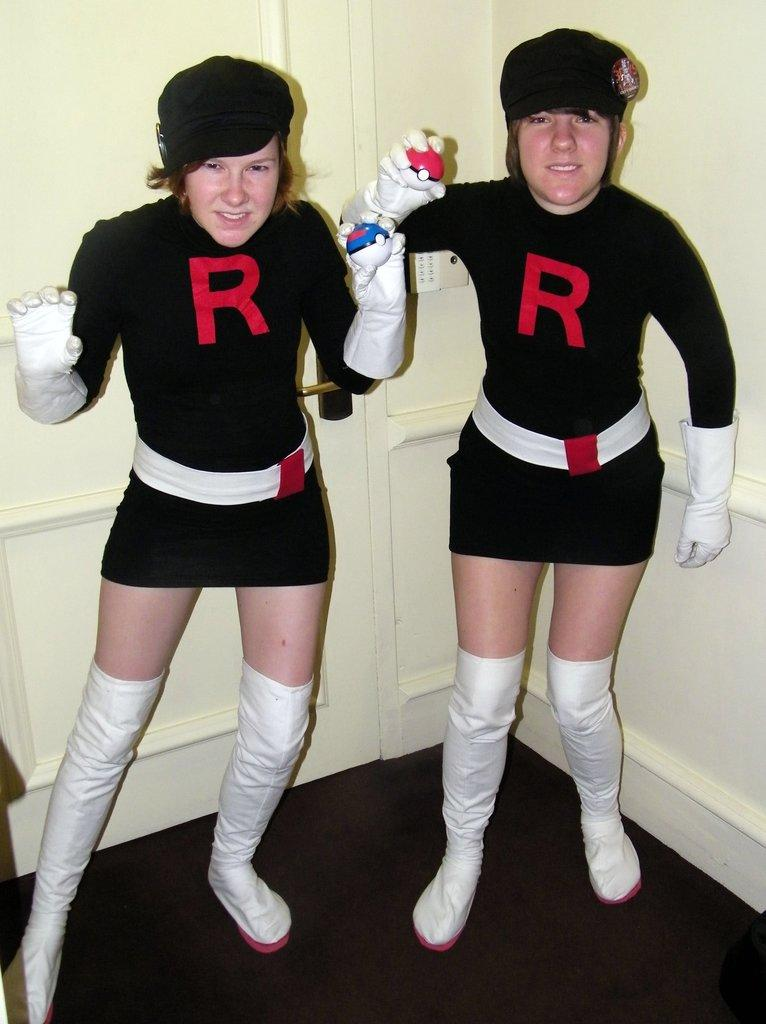Provide a one-sentence caption for the provided image. A couple of girls posing beside each other wearing dresses with an R on it. 